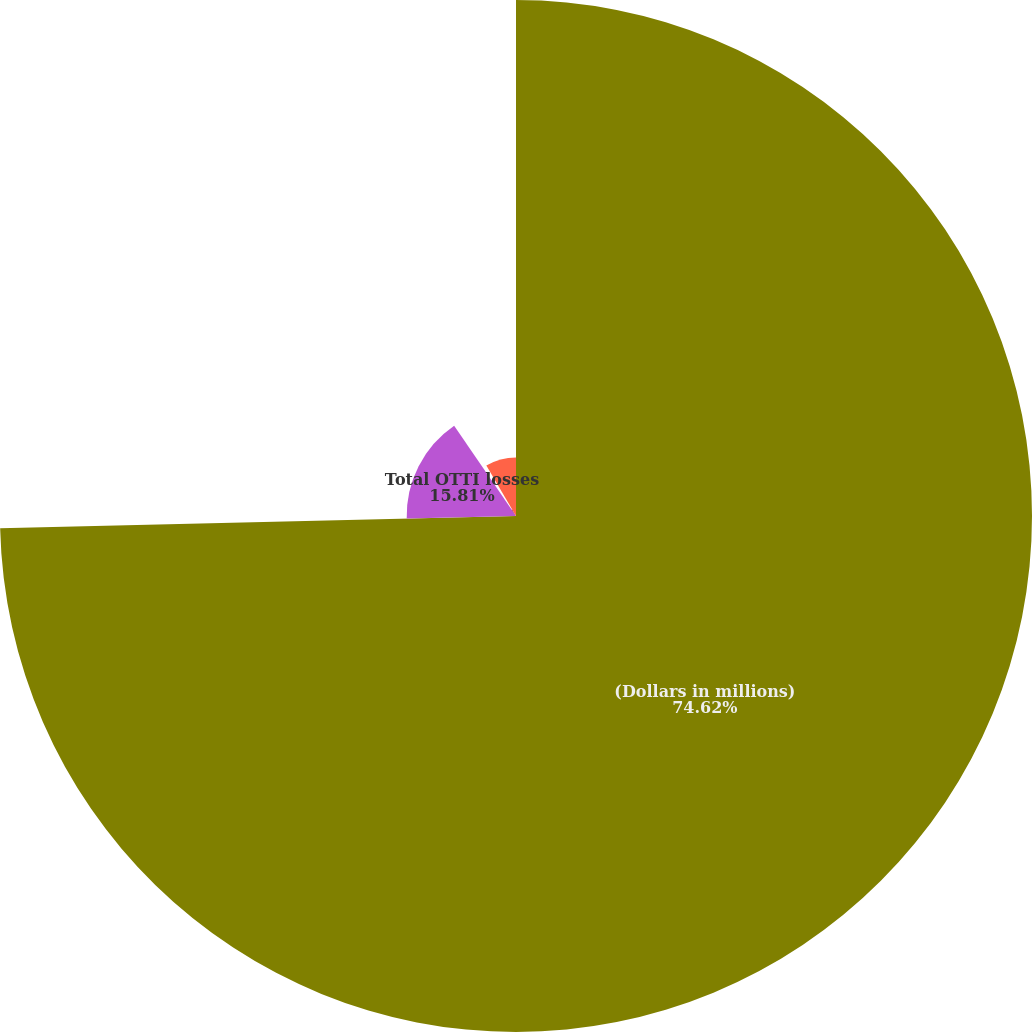Convert chart. <chart><loc_0><loc_0><loc_500><loc_500><pie_chart><fcel>(Dollars in millions)<fcel>Total OTTI losses<fcel>Less non-credit portion of<fcel>Net credit-related impairment<nl><fcel>74.62%<fcel>15.81%<fcel>1.11%<fcel>8.46%<nl></chart> 